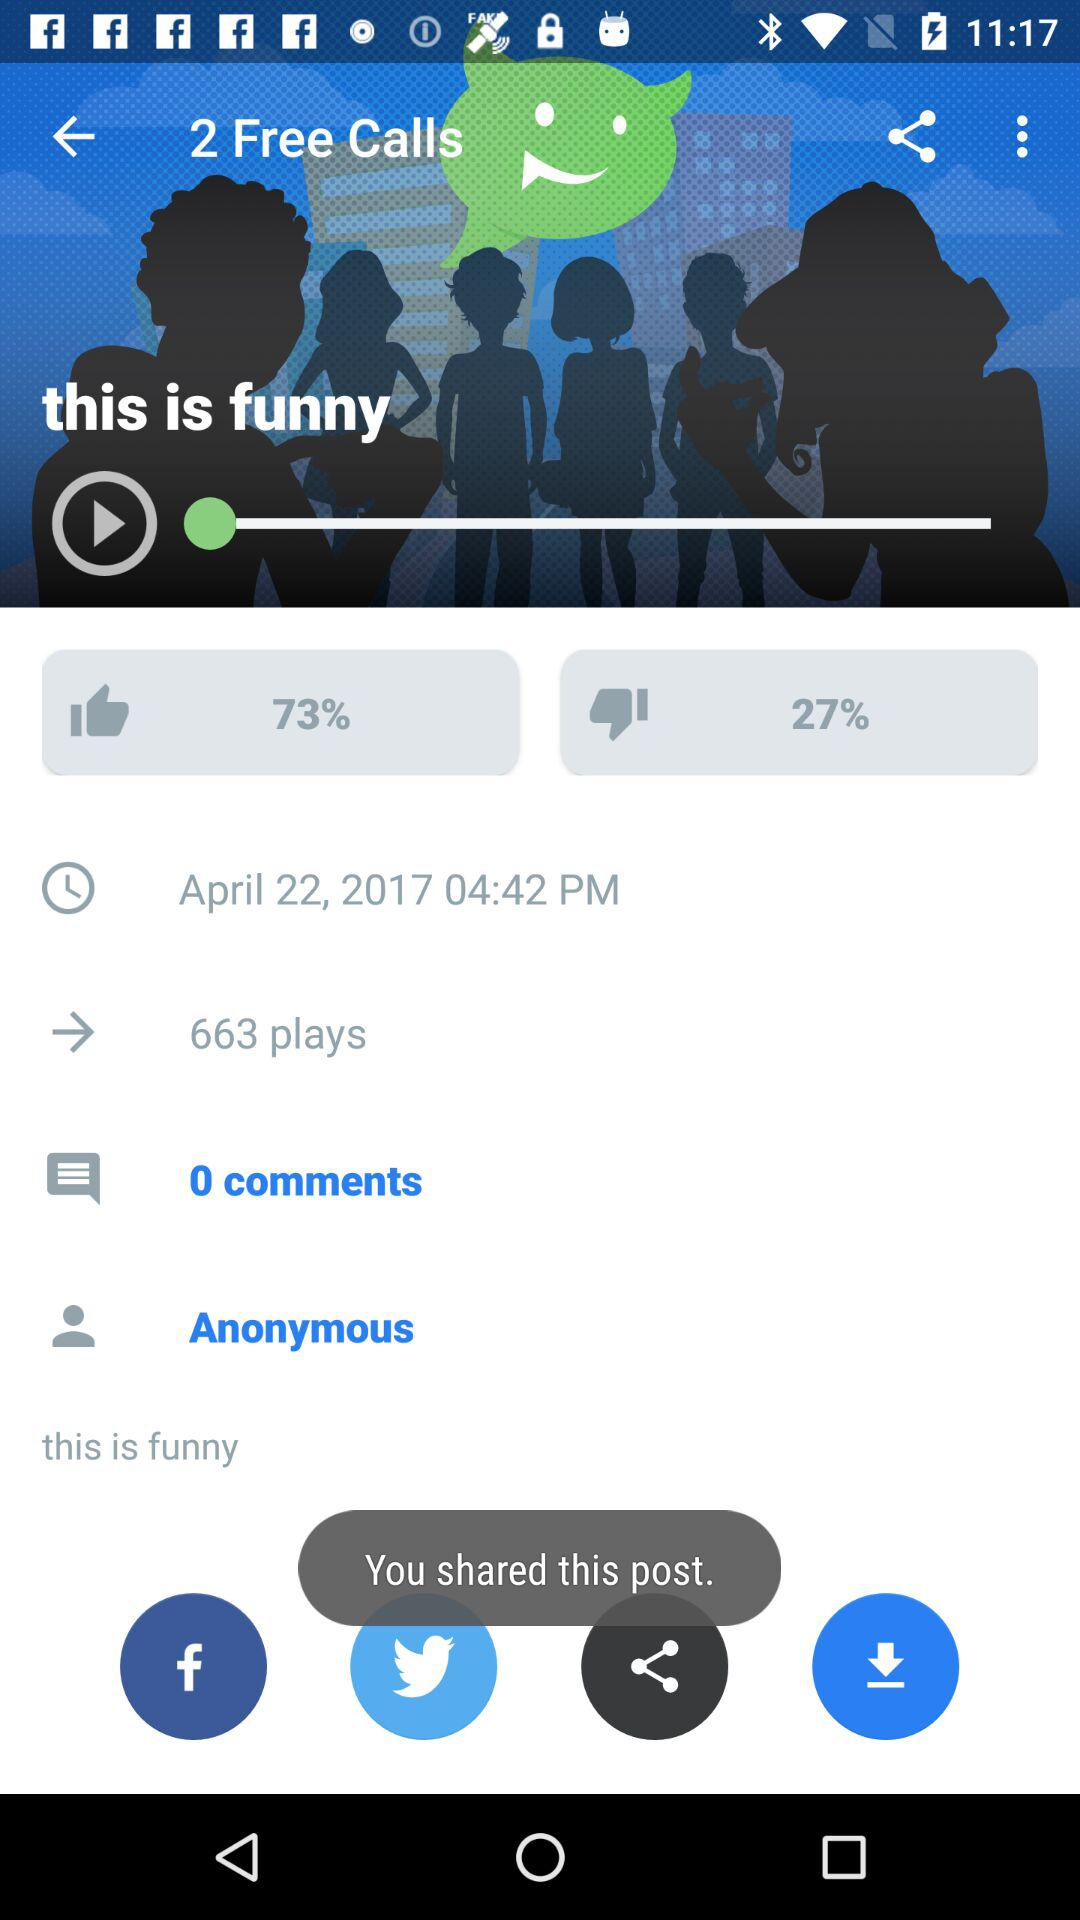What is the like percentage? The like percentage is 73. 